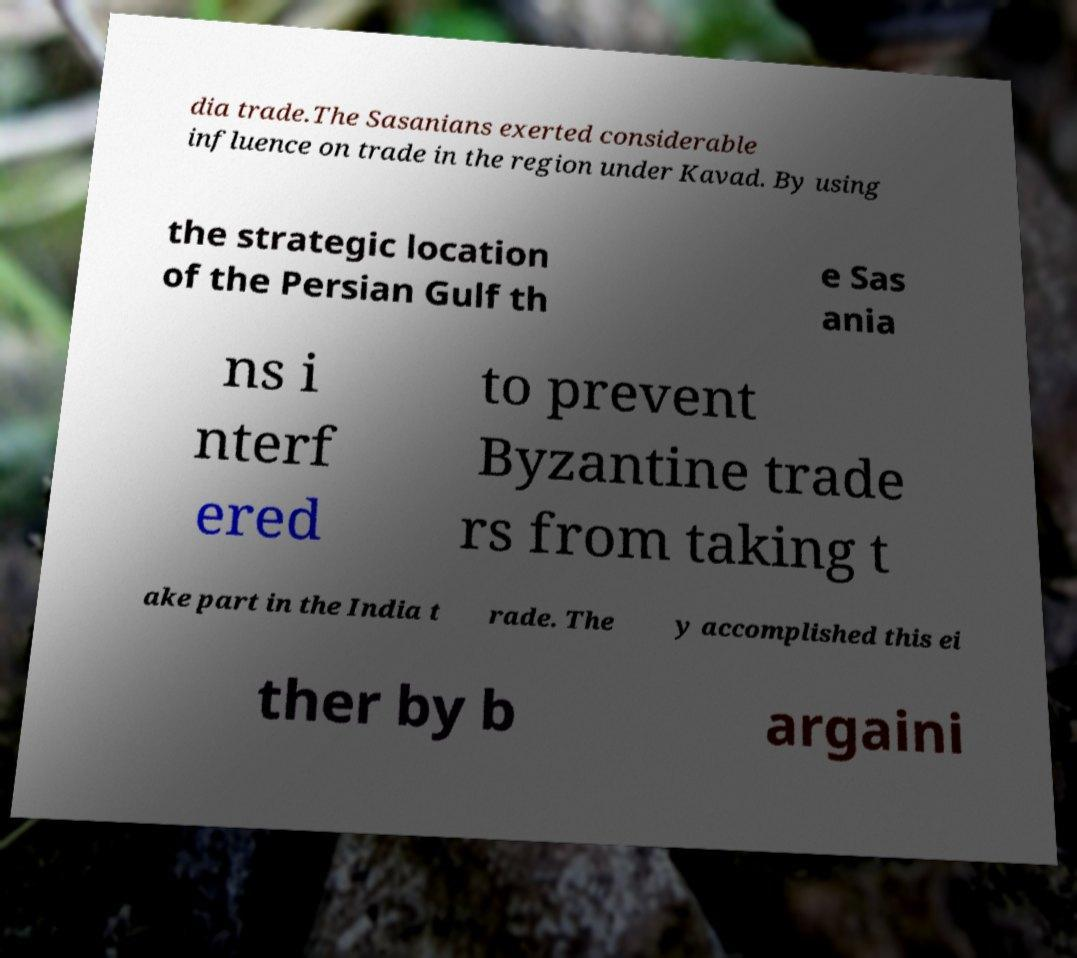There's text embedded in this image that I need extracted. Can you transcribe it verbatim? dia trade.The Sasanians exerted considerable influence on trade in the region under Kavad. By using the strategic location of the Persian Gulf th e Sas ania ns i nterf ered to prevent Byzantine trade rs from taking t ake part in the India t rade. The y accomplished this ei ther by b argaini 